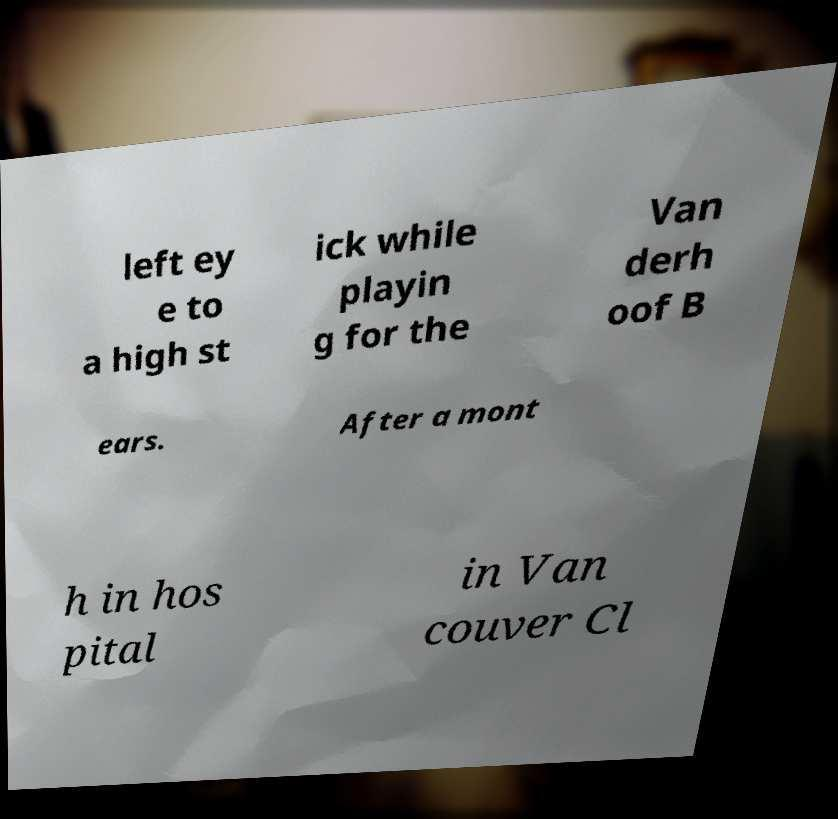I need the written content from this picture converted into text. Can you do that? left ey e to a high st ick while playin g for the Van derh oof B ears. After a mont h in hos pital in Van couver Cl 